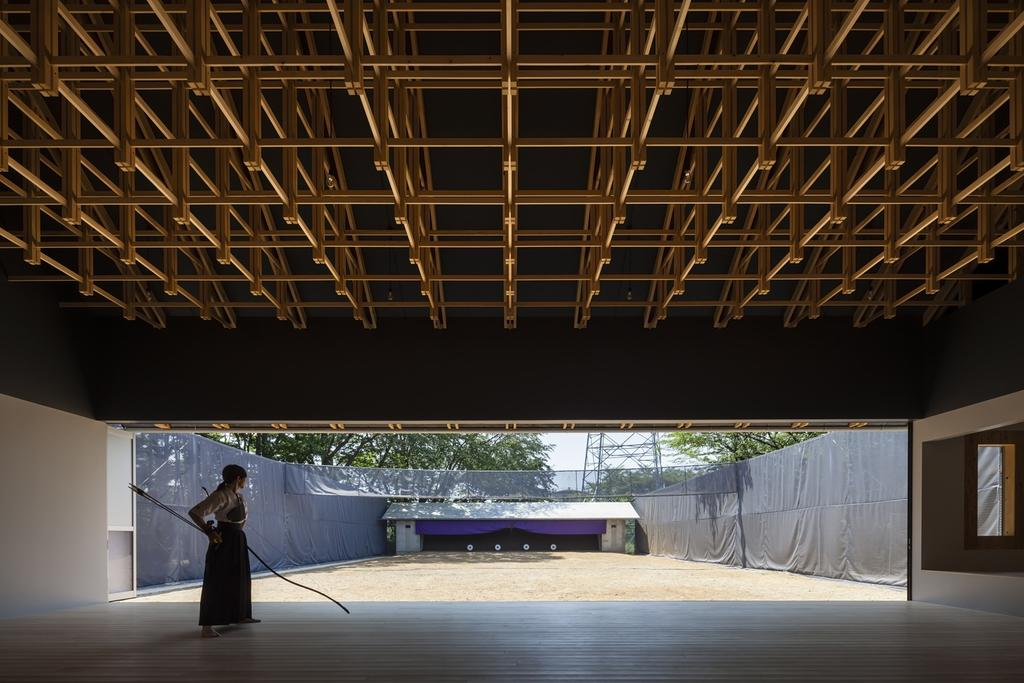What structure can be seen in the image? There is a shed in the image. Who is present in the shed? A lady is standing in the shed. What is the lady holding in the image? The lady is holding sticks. What can be seen in the background of the image? There are trees and a tower in the background of the image. What type of covering is on top of the shed? The shed has a roof. What type of coal is being used to create the bead necklace in the image? There is no coal or bead necklace present in the image. 